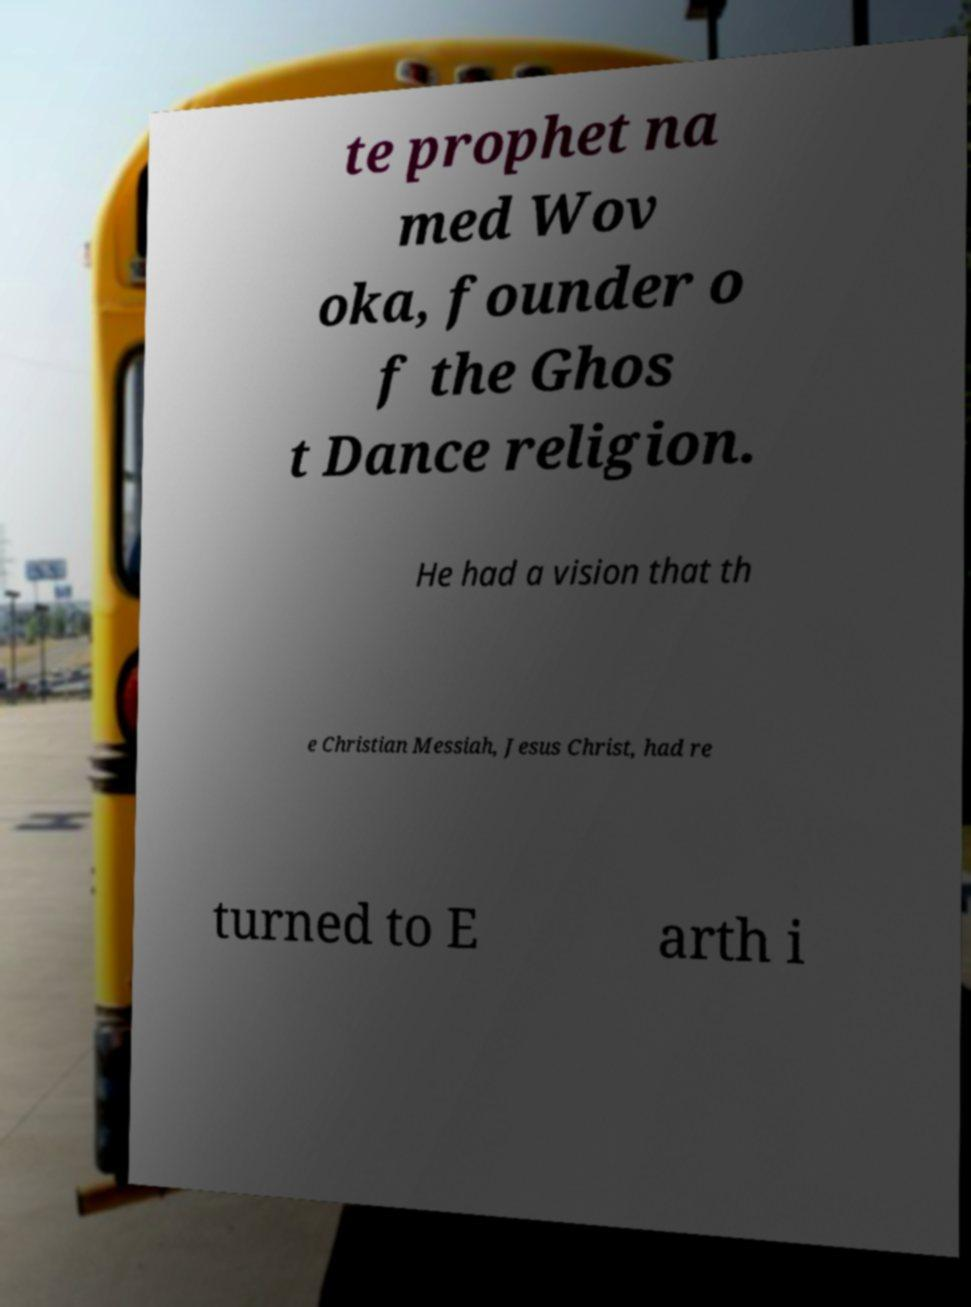Could you extract and type out the text from this image? te prophet na med Wov oka, founder o f the Ghos t Dance religion. He had a vision that th e Christian Messiah, Jesus Christ, had re turned to E arth i 